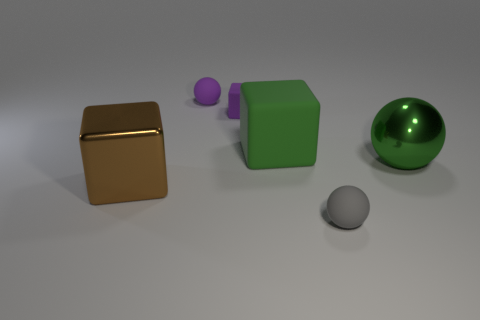What can you tell me about the lighting and shadows in the scene? The scene is softly lit from the upper left side, resulting in diffuse shadows on the right side of the objects. The shadows are not very dark, which indicates the lighting is not harsh. This kind of lighting suggests an indoor setting with either studio lighting or soft natural light from a nearby window. 